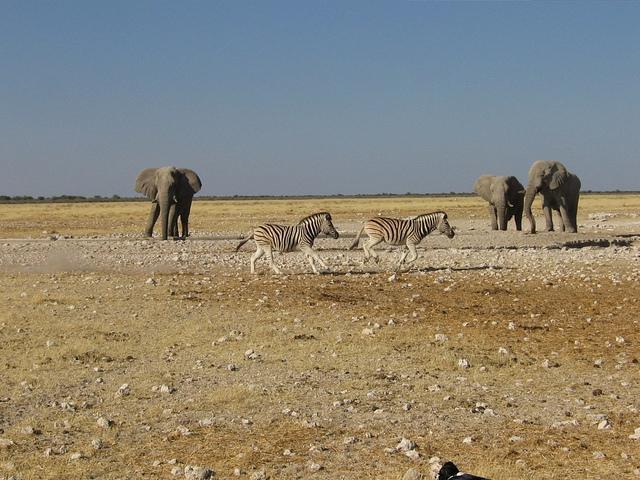How many animals are running?
Give a very brief answer. 2. How many different types of animals are there?
Give a very brief answer. 2. How many zebras are in the picture?
Give a very brief answer. 2. How many elephants are there?
Give a very brief answer. 2. How many giraffes are there?
Give a very brief answer. 0. 